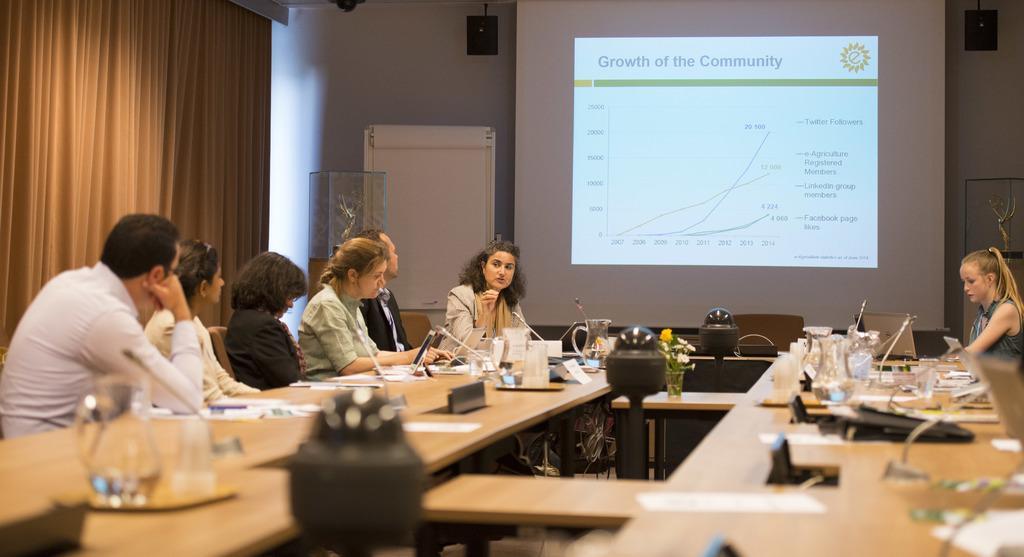Describe this image in one or two sentences. This image is clicked in a room where there is a curtain on the left side. There are tables and chairs. People are sitting around the table on the chairs. On the table there are mike's, laptops, papers, napkins, jar, glass. There is a screen in the middle. There are speakers on the top. 